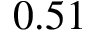<formula> <loc_0><loc_0><loc_500><loc_500>0 . 5 1</formula> 